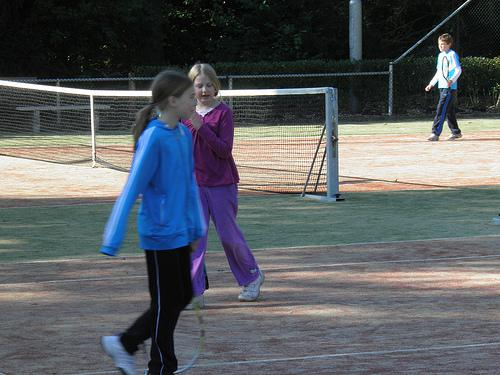Question: what are the girls doing?
Choices:
A. Playing basketball.
B. Having a girl scout meeting.
C. Playing on the soccer field.
D. Dancing.
Answer with the letter. Answer: C Question: what are the girls wearing?
Choices:
A. Bathing suits.
B. Tutus.
C. Sweat suits.
D. Tiaras.
Answer with the letter. Answer: C Question: when did they go to the soccer field?
Choices:
A. Night.
B. Morning.
C. During the day.
D. Sunset.
Answer with the letter. Answer: C Question: what is the boy doing?
Choices:
A. Shooting.
B. Running.
C. Jumping.
D. Playing alone.
Answer with the letter. Answer: D 